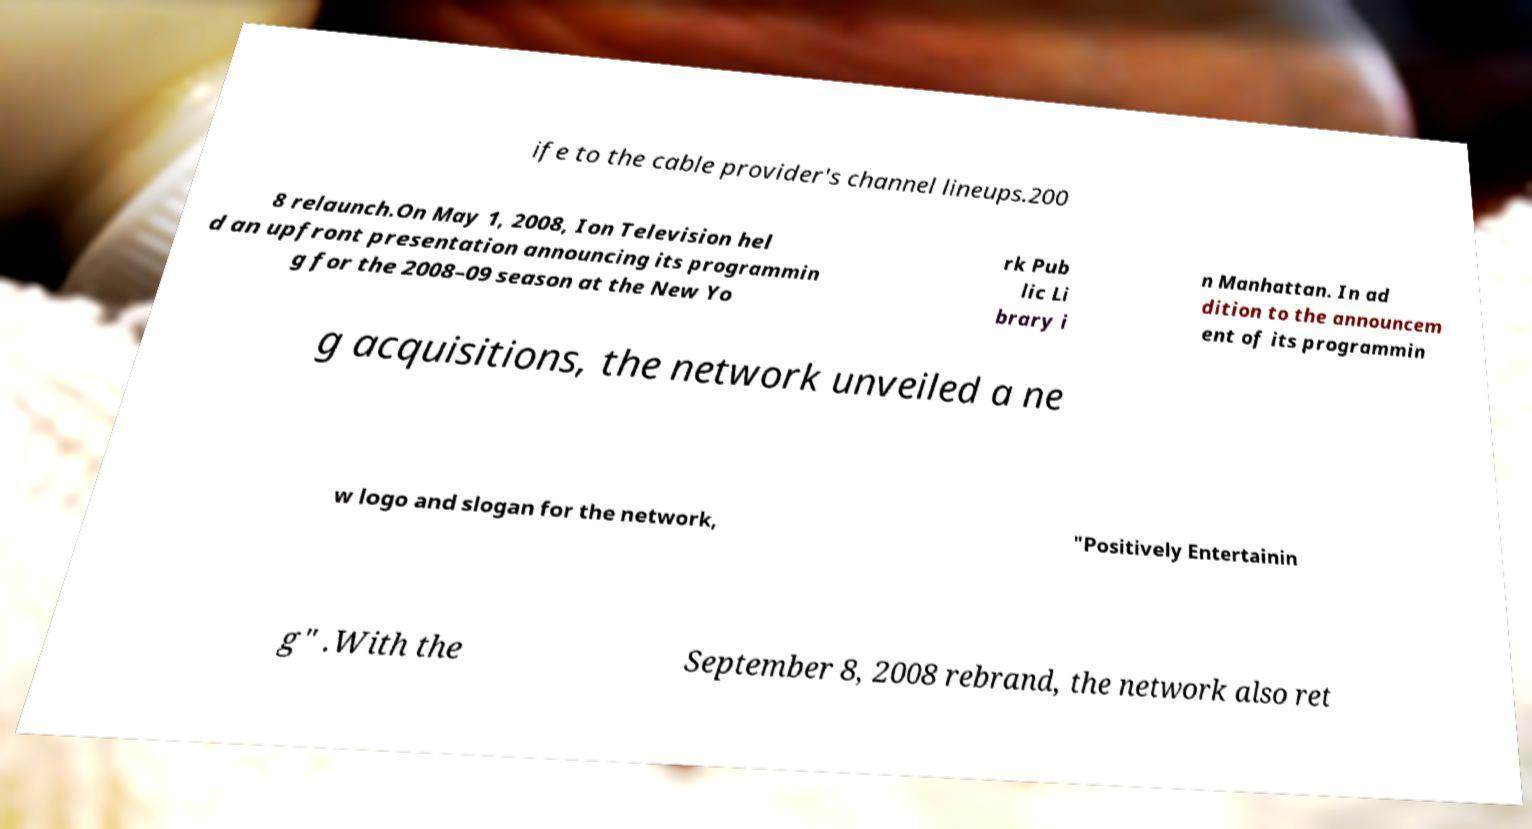For documentation purposes, I need the text within this image transcribed. Could you provide that? ife to the cable provider's channel lineups.200 8 relaunch.On May 1, 2008, Ion Television hel d an upfront presentation announcing its programmin g for the 2008–09 season at the New Yo rk Pub lic Li brary i n Manhattan. In ad dition to the announcem ent of its programmin g acquisitions, the network unveiled a ne w logo and slogan for the network, "Positively Entertainin g" .With the September 8, 2008 rebrand, the network also ret 